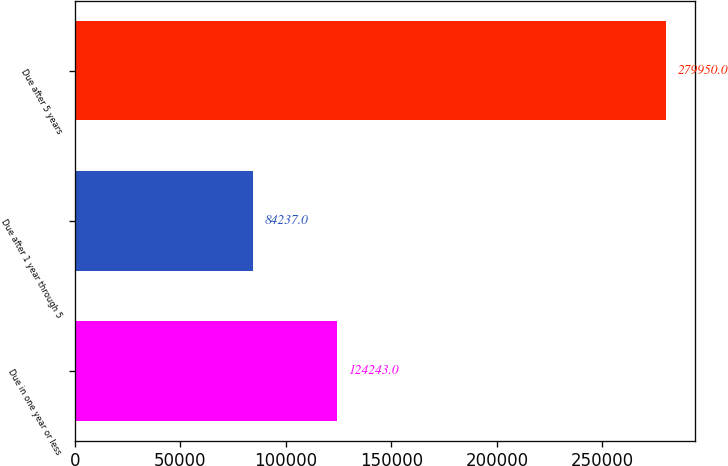Convert chart. <chart><loc_0><loc_0><loc_500><loc_500><bar_chart><fcel>Due in one year or less<fcel>Due after 1 year through 5<fcel>Due after 5 years<nl><fcel>124243<fcel>84237<fcel>279950<nl></chart> 